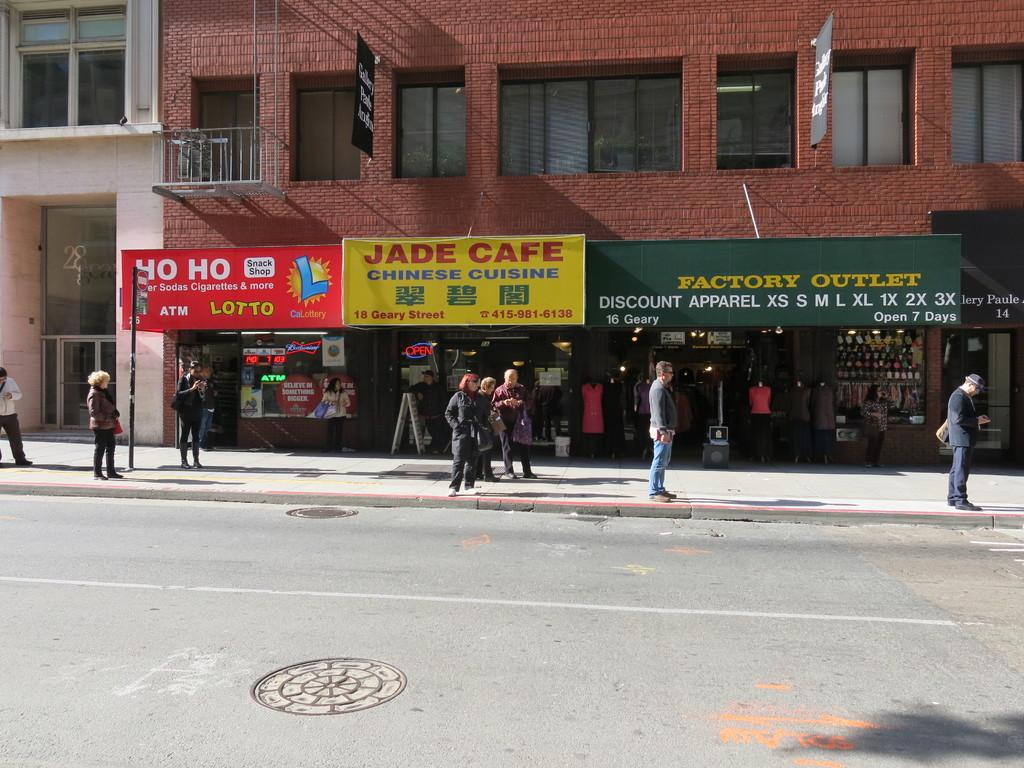What is the main feature of the image? There is a road in the image. What else can be seen on the road? There are boards on a pole in the image. Are there any people in the image? Yes, there are people in the image. What can be seen in the background of the image? There are buildings, a railing, boards, stores, and windows in the background of the image. What type of stamp can be seen on the railing in the image? There is no stamp present on the railing in the image. What is the opinion of the machine in the image? There is no machine present in the image, so it is not possible to determine its opinion. 